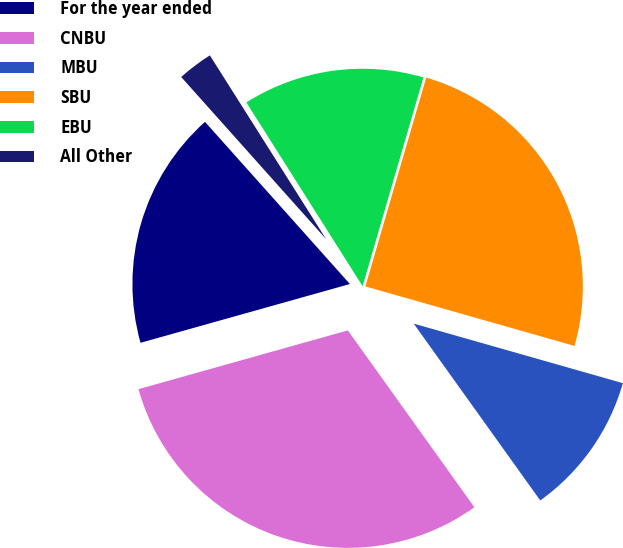Convert chart to OTSL. <chart><loc_0><loc_0><loc_500><loc_500><pie_chart><fcel>For the year ended<fcel>CNBU<fcel>MBU<fcel>SBU<fcel>EBU<fcel>All Other<nl><fcel>17.75%<fcel>30.53%<fcel>10.7%<fcel>24.9%<fcel>13.49%<fcel>2.63%<nl></chart> 